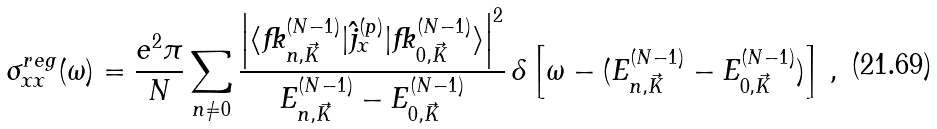Convert formula to latex. <formula><loc_0><loc_0><loc_500><loc_500>\sigma ^ { r e g } _ { x x } ( \omega ) = \frac { e ^ { 2 } \pi } { N } \sum _ { n \neq 0 } \frac { \left | \langle { \mathit \Psi } _ { n , \vec { K } } ^ { ( N - 1 ) } | \hat { j } _ { x } ^ { ( p ) } | { \mathit \Psi } _ { 0 , \vec { K } } ^ { ( N - 1 ) } \rangle \right | ^ { 2 } } { E ^ { ( N - 1 ) } _ { n , \vec { K } } - E ^ { ( N - 1 ) } _ { 0 , \vec { K } } } \, \delta \left [ \omega - ( E _ { n , \vec { K } } ^ { ( N - 1 ) } - E _ { 0 , \vec { K } } ^ { ( N - 1 ) } ) \right ] \, ,</formula> 